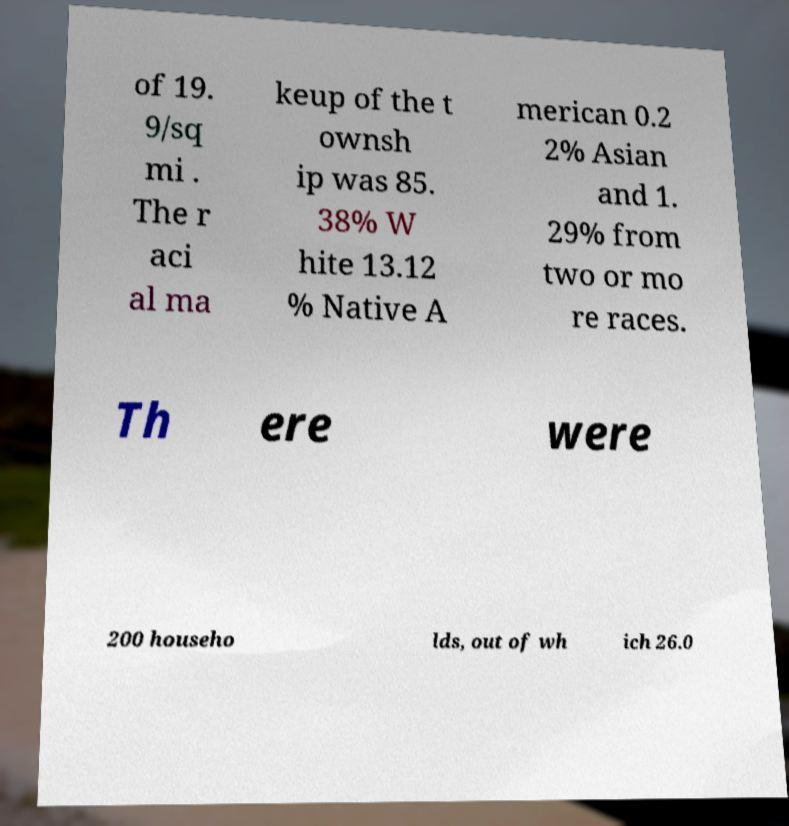Could you extract and type out the text from this image? of 19. 9/sq mi . The r aci al ma keup of the t ownsh ip was 85. 38% W hite 13.12 % Native A merican 0.2 2% Asian and 1. 29% from two or mo re races. Th ere were 200 househo lds, out of wh ich 26.0 